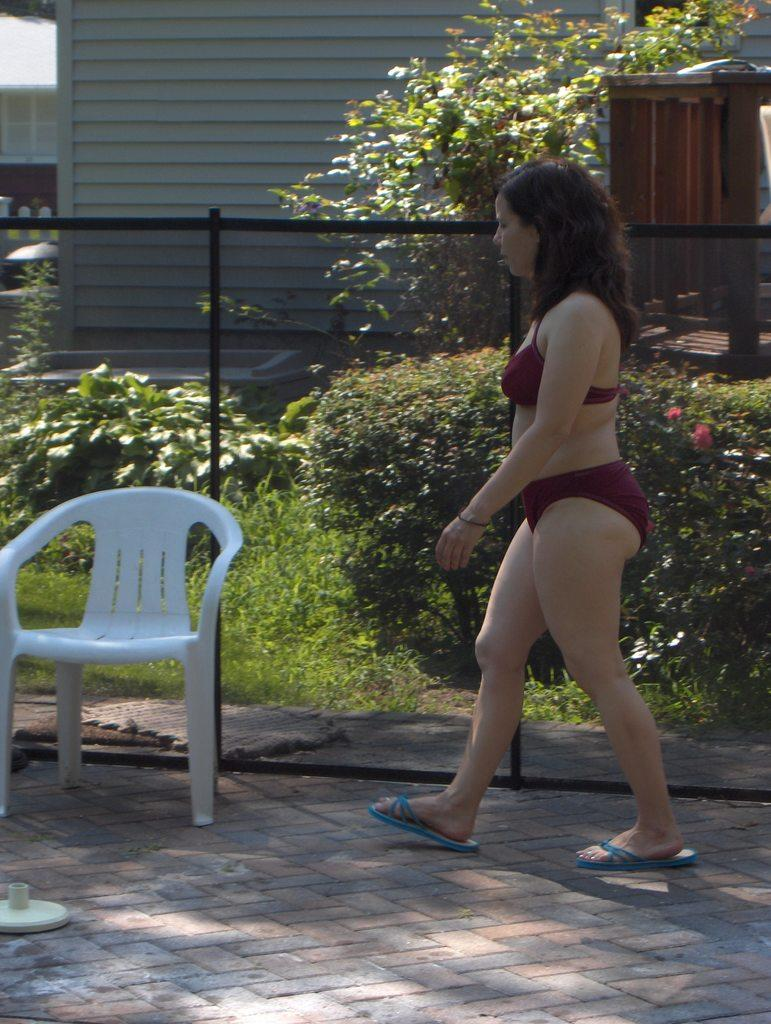What is the woman in the image doing? The woman is walking in the image. On what surface is the woman walking? The woman is walking on the ground. What object can be seen in the image that is typically used for holding plants? There is a chair for plants in the image. What type of structure is visible in the image? There is a house in the image. What type of knife can be seen hanging on the wall in the image? There is no knife present in the image. 